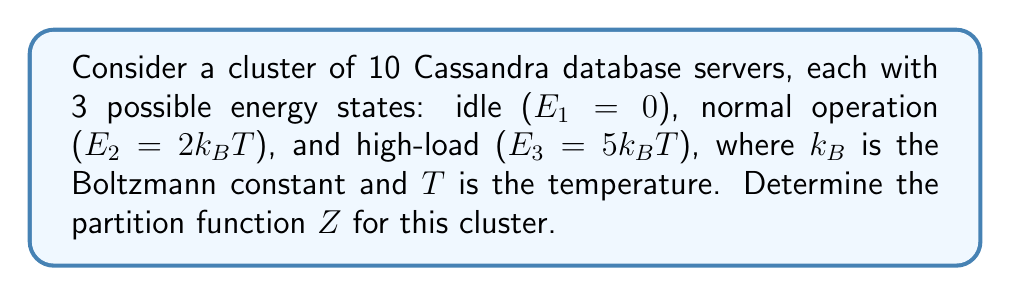Could you help me with this problem? To solve this problem, we'll follow these steps:

1) The partition function $Z$ for a system with discrete energy levels is given by:

   $$Z = \sum_i g_i e^{-E_i/k_BT}$$

   where $g_i$ is the degeneracy of the $i$-th energy level and $E_i$ is its energy.

2) In our case, we have 3 energy levels for each server:
   $E_1 = 0$, $E_2 = 2k_BT$, $E_3 = 5k_BT$

3) The partition function for a single server is:

   $$Z_1 = e^{-E_1/k_BT} + e^{-E_2/k_BT} + e^{-E_3/k_BT}$$

4) Substituting the energy values:

   $$Z_1 = e^0 + e^{-2} + e^{-5} = 1 + e^{-2} + e^{-5}$$

5) For a system of 10 independent servers, the total partition function is the product of individual partition functions:

   $$Z = (Z_1)^{10} = (1 + e^{-2} + e^{-5})^{10}$$

This is the final form of the partition function for the cluster.
Answer: $Z = (1 + e^{-2} + e^{-5})^{10}$ 